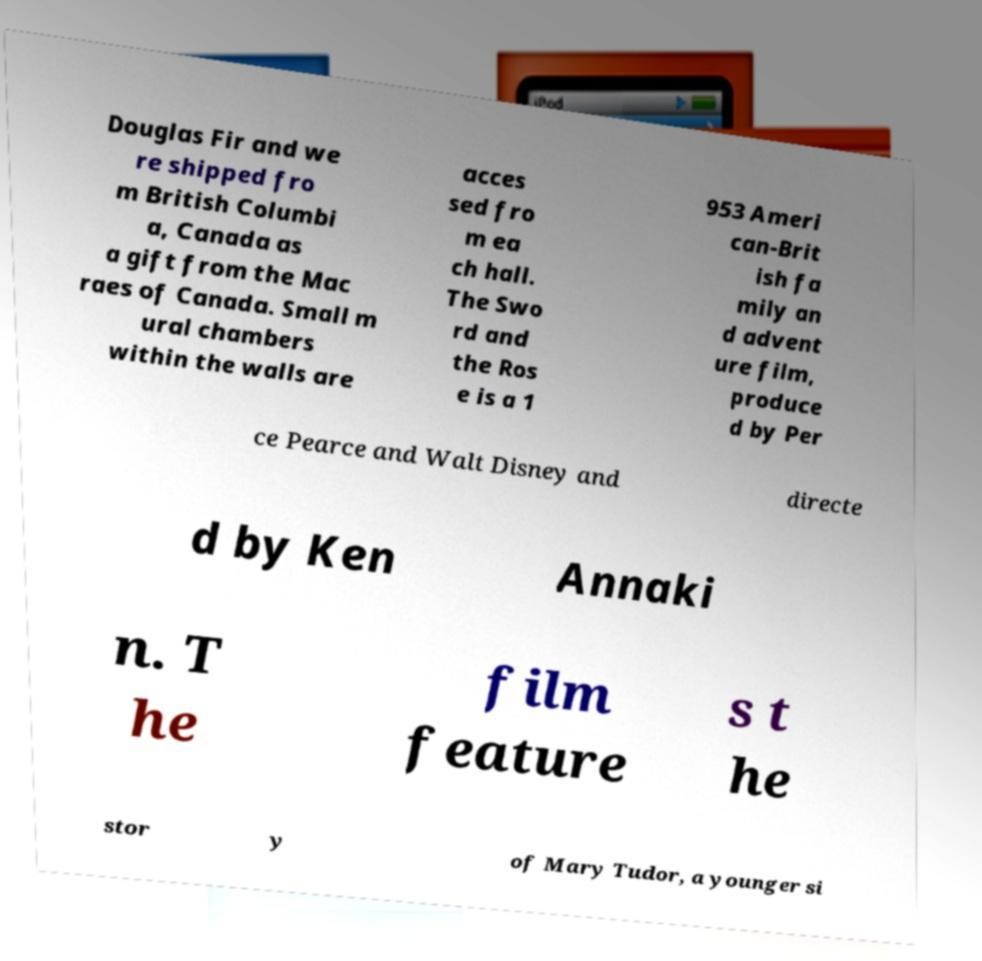Can you accurately transcribe the text from the provided image for me? Douglas Fir and we re shipped fro m British Columbi a, Canada as a gift from the Mac raes of Canada. Small m ural chambers within the walls are acces sed fro m ea ch hall. The Swo rd and the Ros e is a 1 953 Ameri can-Brit ish fa mily an d advent ure film, produce d by Per ce Pearce and Walt Disney and directe d by Ken Annaki n. T he film feature s t he stor y of Mary Tudor, a younger si 